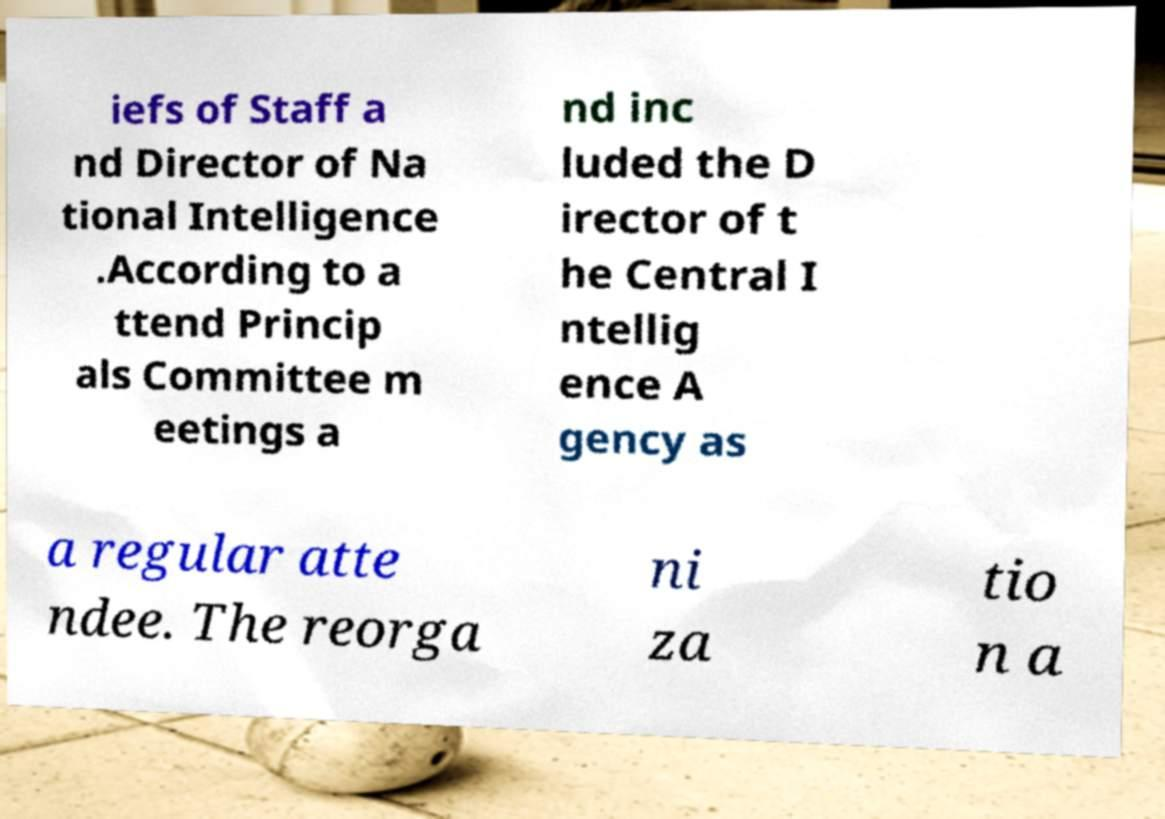For documentation purposes, I need the text within this image transcribed. Could you provide that? iefs of Staff a nd Director of Na tional Intelligence .According to a ttend Princip als Committee m eetings a nd inc luded the D irector of t he Central I ntellig ence A gency as a regular atte ndee. The reorga ni za tio n a 